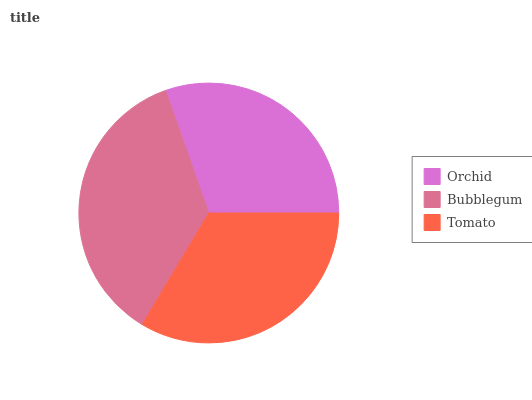Is Orchid the minimum?
Answer yes or no. Yes. Is Bubblegum the maximum?
Answer yes or no. Yes. Is Tomato the minimum?
Answer yes or no. No. Is Tomato the maximum?
Answer yes or no. No. Is Bubblegum greater than Tomato?
Answer yes or no. Yes. Is Tomato less than Bubblegum?
Answer yes or no. Yes. Is Tomato greater than Bubblegum?
Answer yes or no. No. Is Bubblegum less than Tomato?
Answer yes or no. No. Is Tomato the high median?
Answer yes or no. Yes. Is Tomato the low median?
Answer yes or no. Yes. Is Orchid the high median?
Answer yes or no. No. Is Orchid the low median?
Answer yes or no. No. 